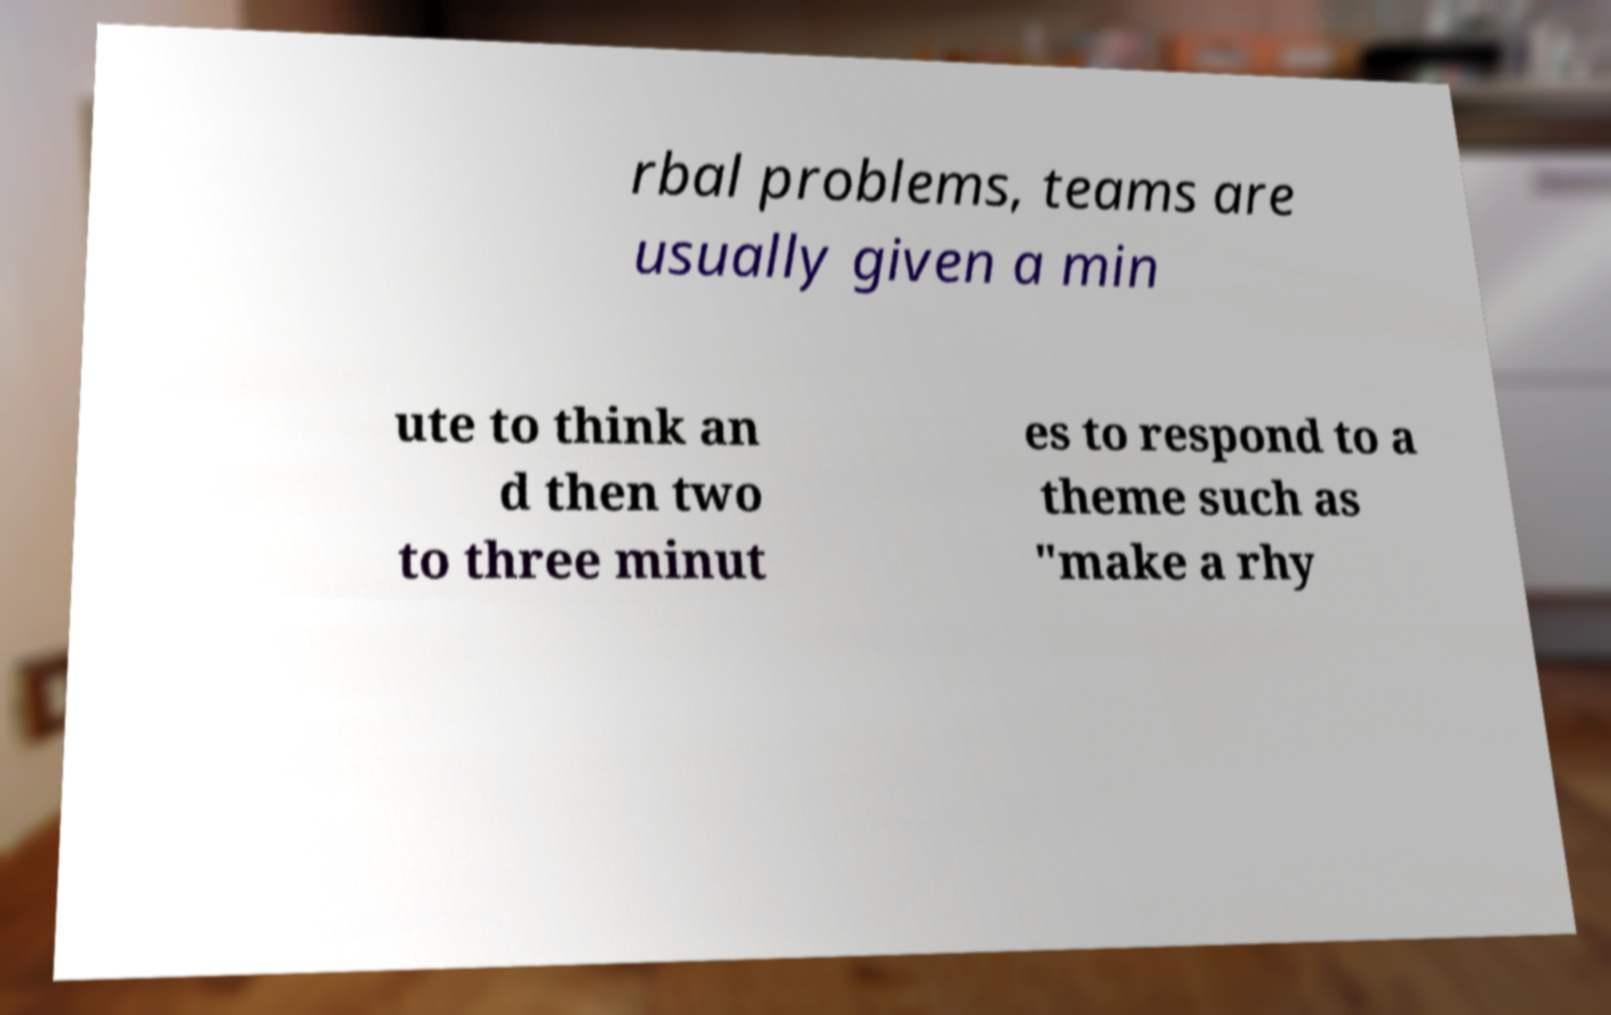Could you assist in decoding the text presented in this image and type it out clearly? rbal problems, teams are usually given a min ute to think an d then two to three minut es to respond to a theme such as "make a rhy 